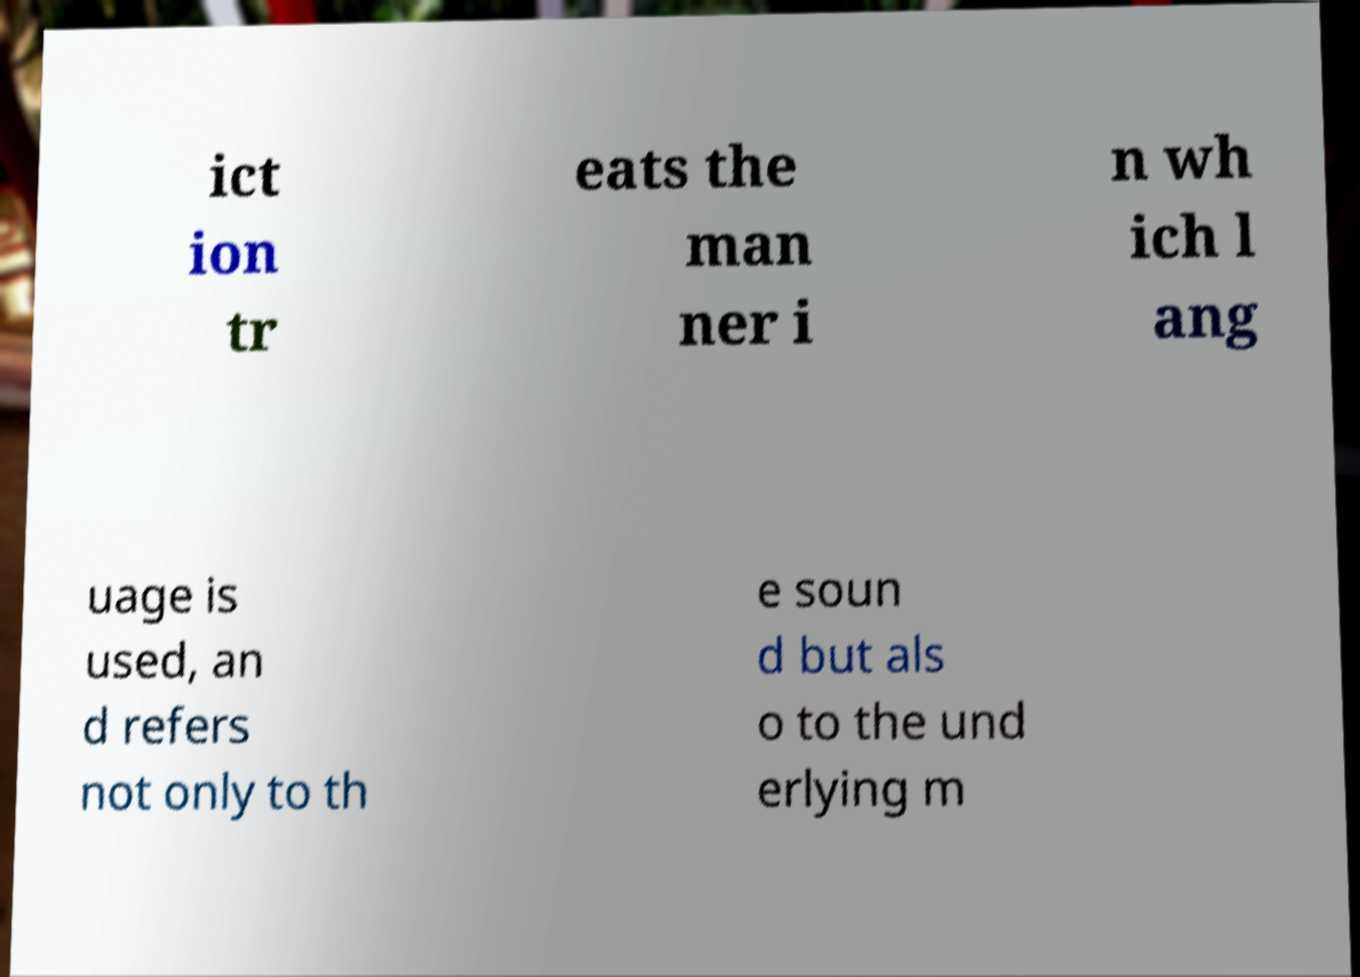Can you read and provide the text displayed in the image?This photo seems to have some interesting text. Can you extract and type it out for me? ict ion tr eats the man ner i n wh ich l ang uage is used, an d refers not only to th e soun d but als o to the und erlying m 